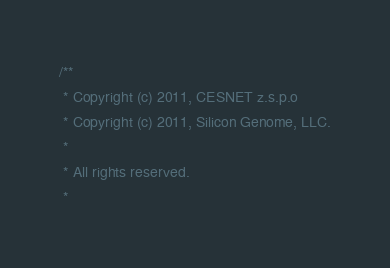<code> <loc_0><loc_0><loc_500><loc_500><_Cuda_>/**
 * Copyright (c) 2011, CESNET z.s.p.o
 * Copyright (c) 2011, Silicon Genome, LLC.
 *
 * All rights reserved.
 *</code> 